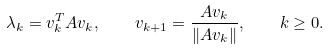Convert formula to latex. <formula><loc_0><loc_0><loc_500><loc_500>\lambda _ { k } = v _ { k } ^ { T } A v _ { k } , \quad v _ { k + 1 } = \frac { A v _ { k } } { \| A v _ { k } \| } , \quad k \geq 0 .</formula> 